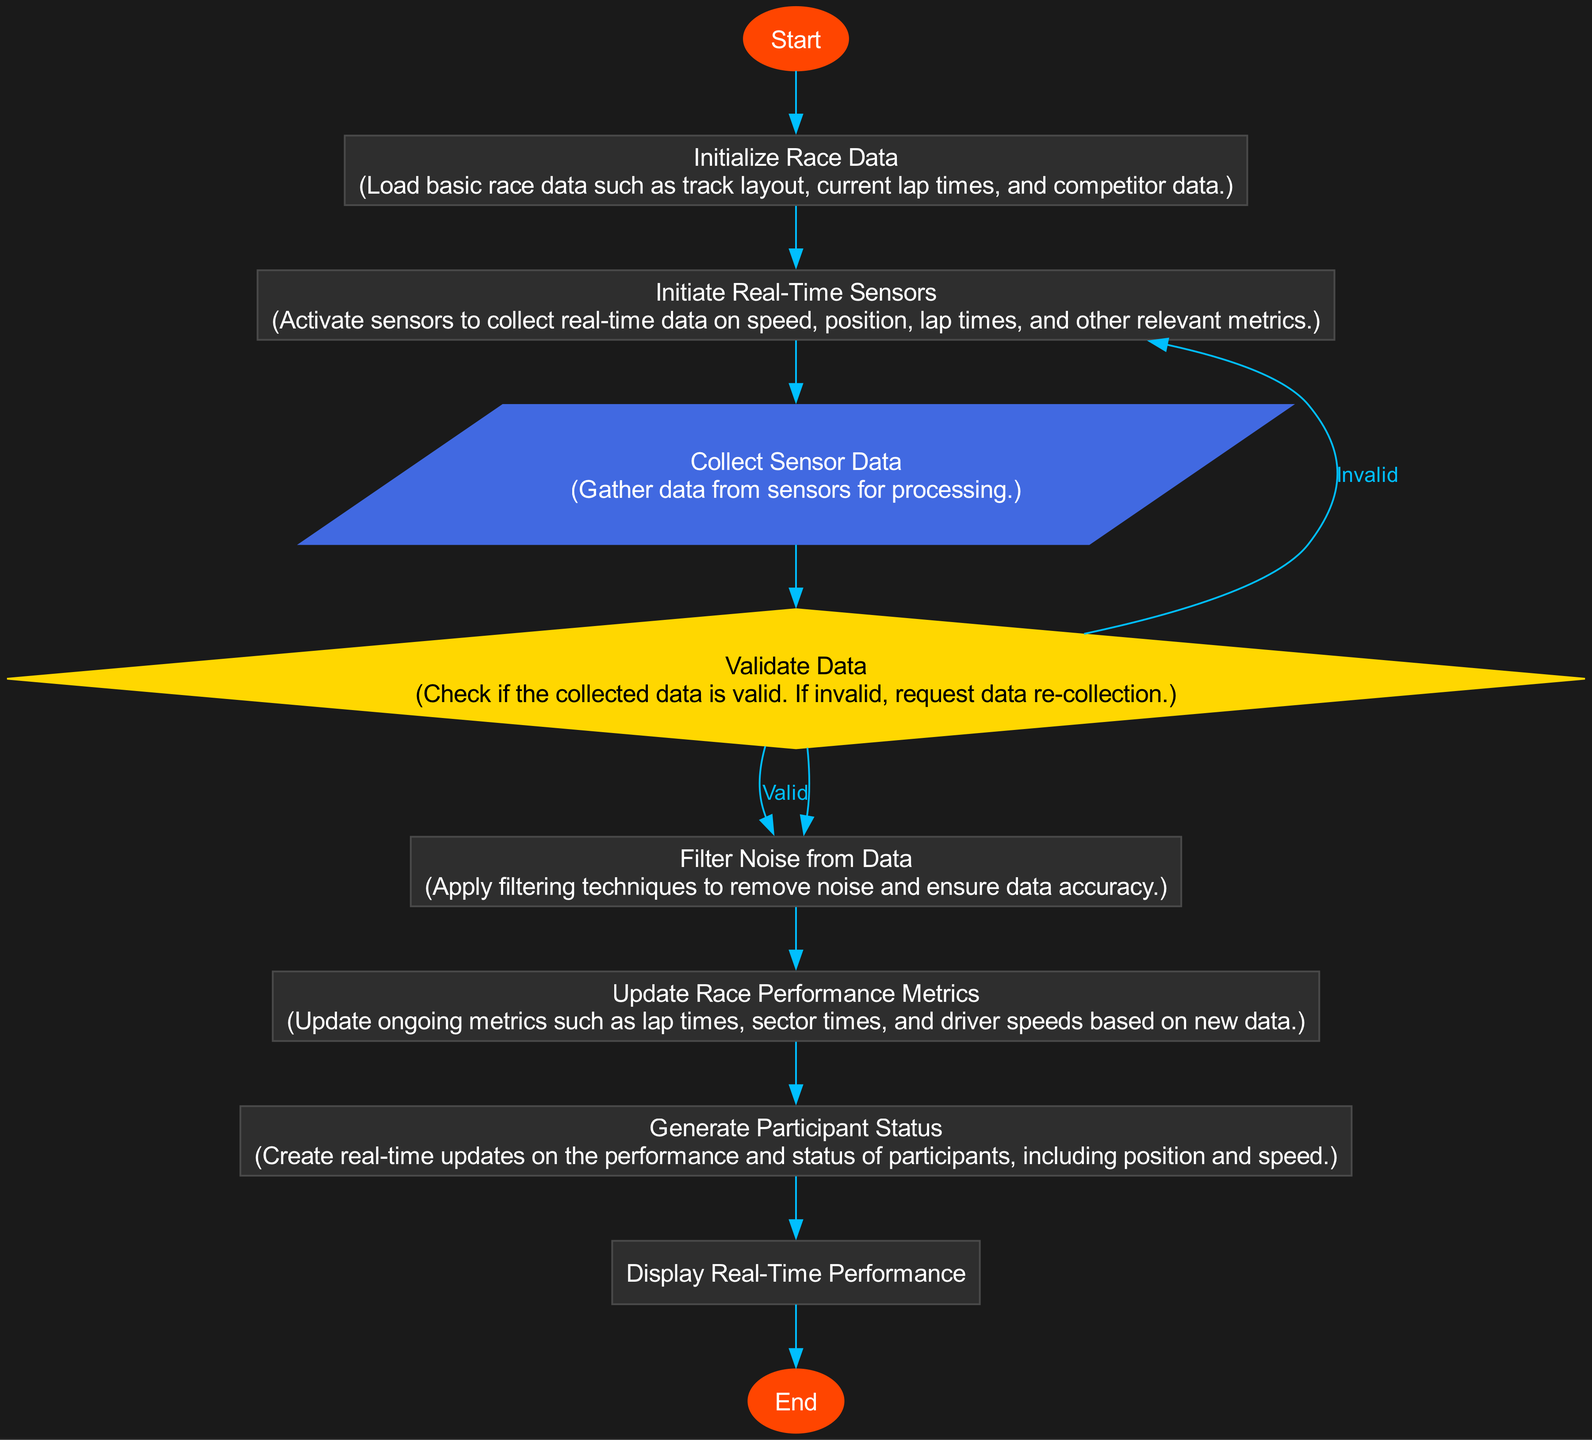What is the first step in the diagram? The first step, or starting node, is labeled "Start". This indicates the beginning of the flowchart.
Answer: Start How many processes are there in the diagram? By counting the nodes classified as "Process" type, we find six instances: "Initialize Race Data", "Initiate Real-Time Sensors", "Filter Noise from Data", "Update Race Performance Metrics", "Generate Participant Status", and "Display Real-Time Performance".
Answer: Six What type of node is "Validate Data"? The node "Validate Data" is classified as a "Decision" type, which is used to represent a point where a decision must be made.
Answer: Decision What happens if the data is invalid after validation? If the data is invalid after validation, the flow goes back to the "Collect Sensor Data" node, as indicated by the labeled edge "Invalid".
Answer: Request data re-collection What is the final output of the flowchart? The final output represented in the flowchart is reached with the node "End", which concludes the entire process.
Answer: End What step comes after "Collect Sensor Data"? After "Collect Sensor Data", the next step is "Validate Data", where the collected data is verified for accuracy.
Answer: Validate Data How does the flowchart handle noise in data? The flowchart involves a step titled "Filter Noise from Data" which implements filtering techniques to ensure the accuracy of the data before processing it further.
Answer: Filter Noise from Data What node follows "Initiate Real-Time Sensors"? The node that directly follows "Initiate Real-Time Sensors" is "Collect Sensor Data", indicating a sequential process.
Answer: Collect Sensor Data 